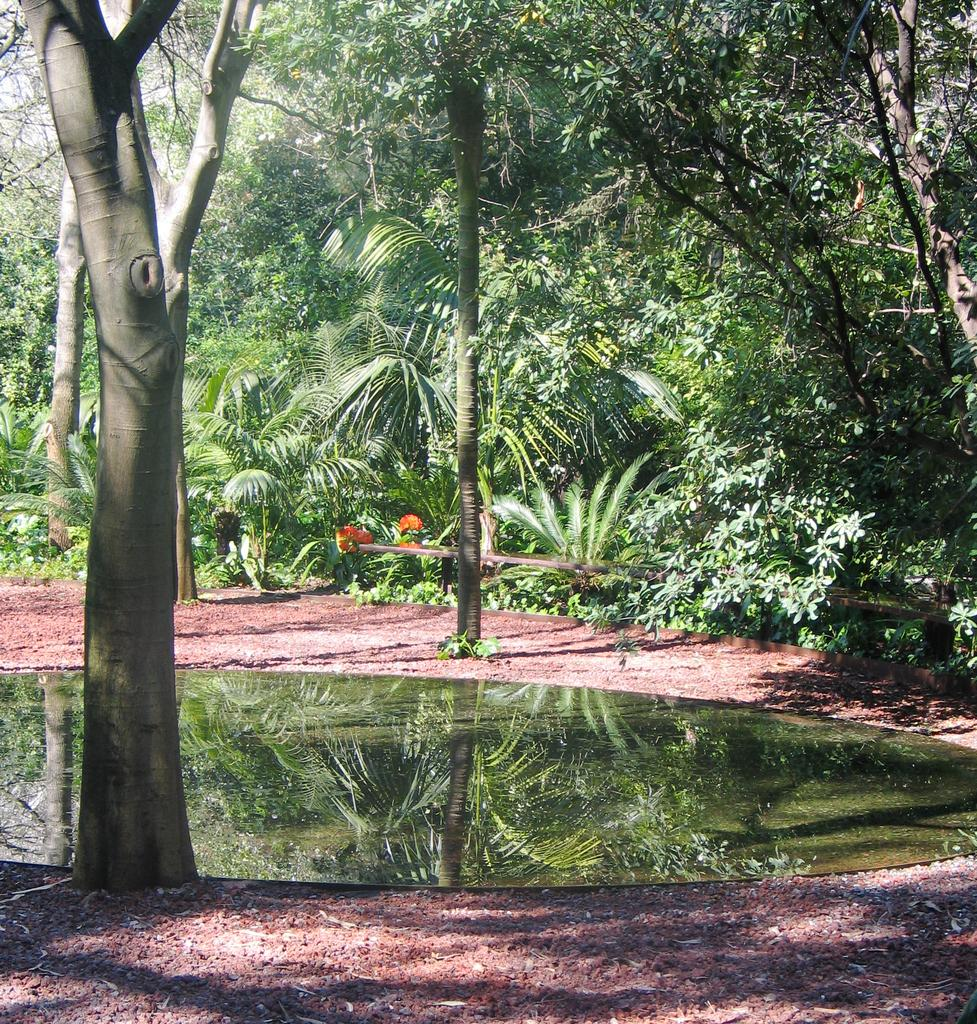What is the primary element visible in the image? There is water in the image. What can be seen at the bottom of the water? There are mud and stones at the bottom of the image. What type of vegetation is visible in the background of the image? There are plants and trees in the background of the image. How many steps can be seen leading up to the ear in the image? There are no steps or ears present in the image. 